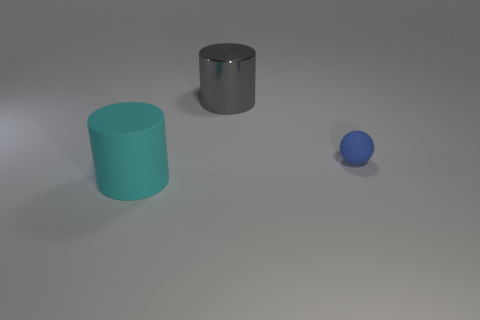What number of things are small red shiny balls or cylinders that are in front of the shiny cylinder?
Provide a succinct answer. 1. What number of other objects are there of the same color as the small thing?
Provide a short and direct response. 0. Does the gray cylinder have the same size as the cylinder on the left side of the big metallic thing?
Your answer should be very brief. Yes. Does the matte object in front of the blue sphere have the same size as the metallic object?
Provide a short and direct response. Yes. What number of other objects are the same material as the blue ball?
Your answer should be compact. 1. Are there an equal number of tiny matte things that are in front of the large shiny cylinder and matte objects that are left of the blue rubber ball?
Keep it short and to the point. Yes. What is the color of the big cylinder to the right of the big cylinder in front of the cylinder that is behind the cyan matte thing?
Ensure brevity in your answer.  Gray. There is a thing left of the large metallic thing; what shape is it?
Keep it short and to the point. Cylinder. There is a cyan object that is the same material as the sphere; what shape is it?
Your response must be concise. Cylinder. Is there anything else that is the same shape as the large metallic thing?
Your answer should be compact. Yes. 